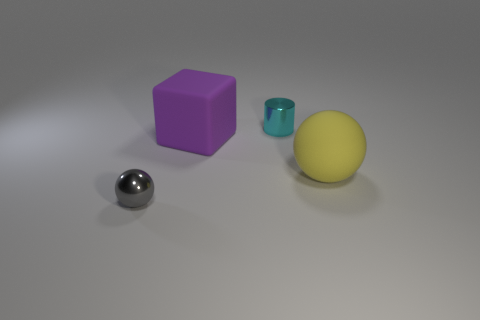What color is the small metallic thing that is behind the ball that is to the right of the cube?
Your response must be concise. Cyan. What is the thing that is both behind the yellow object and in front of the cyan cylinder made of?
Give a very brief answer. Rubber. Is there a big green metallic thing that has the same shape as the big purple object?
Keep it short and to the point. No. Does the small metal object that is behind the shiny ball have the same shape as the large purple object?
Your answer should be compact. No. What number of metallic objects are behind the yellow matte ball and to the left of the tiny cyan object?
Offer a very short reply. 0. There is a metallic thing left of the small metallic cylinder; what is its shape?
Give a very brief answer. Sphere. What number of other tiny objects are made of the same material as the gray object?
Keep it short and to the point. 1. Does the cyan metallic thing have the same shape as the large rubber thing that is behind the big yellow sphere?
Offer a very short reply. No. There is a big object behind the matte thing right of the small cyan metallic cylinder; are there any small metallic cylinders left of it?
Your response must be concise. No. What size is the rubber thing behind the large yellow object?
Make the answer very short. Large. 